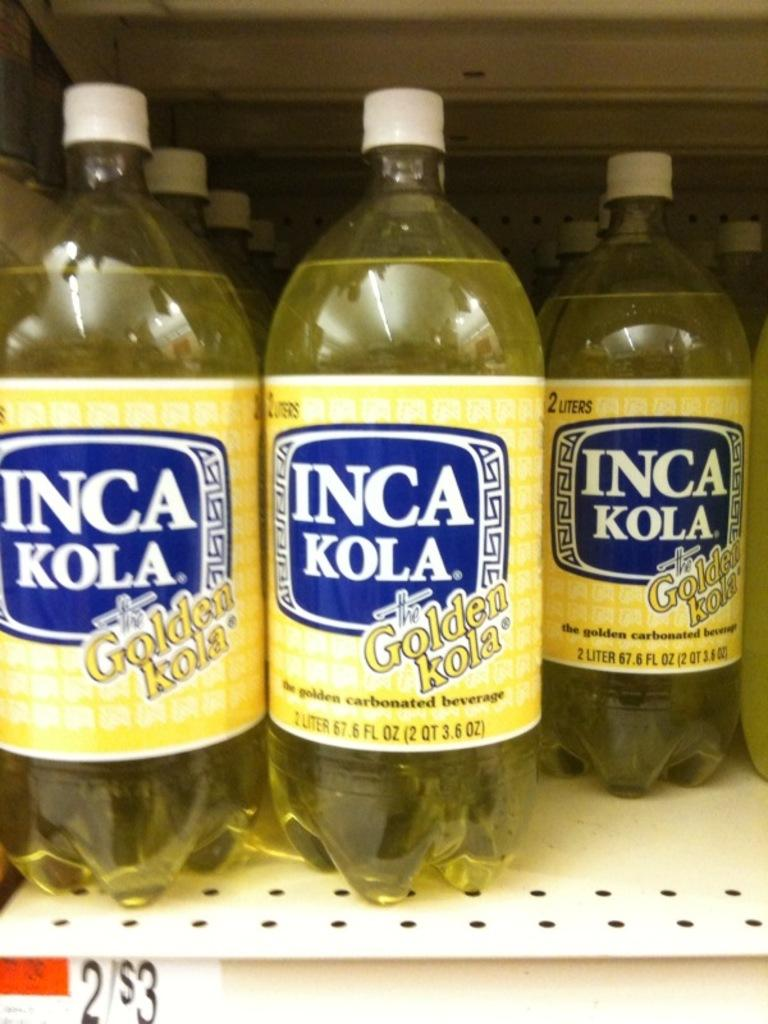<image>
Describe the image concisely. Inca Kola bottles on a shelf are each 2 liters. 